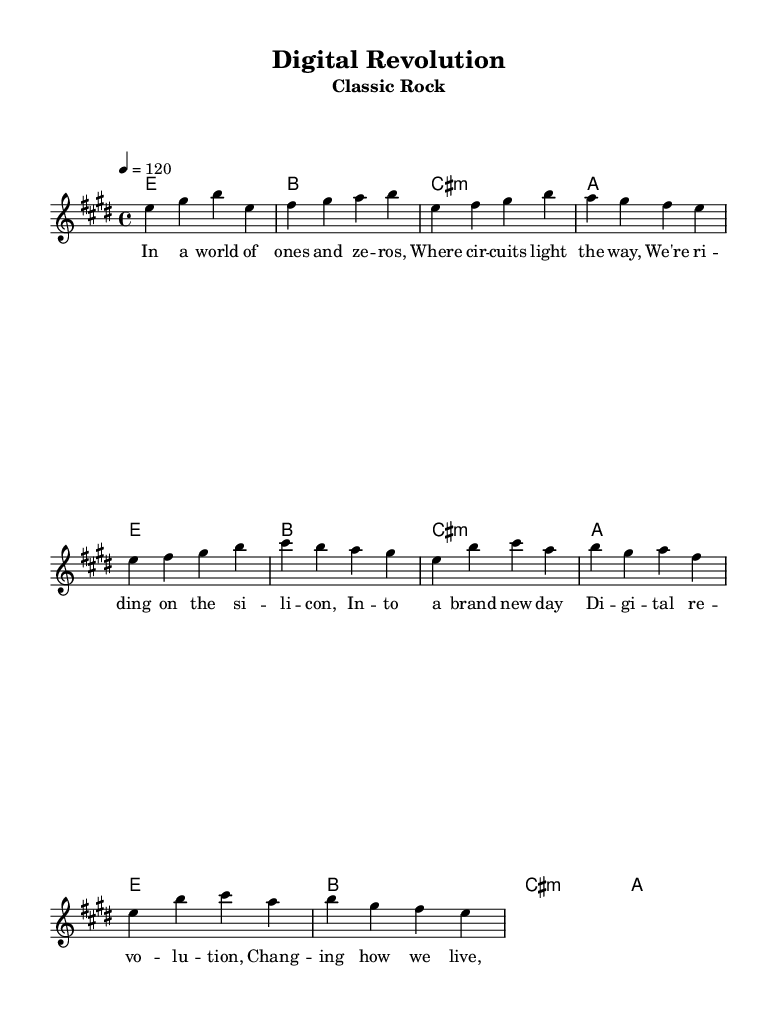What is the key signature of this music? The key signature is indicated in the global section and shows two sharps, which corresponds to E major.
Answer: E major What is the time signature of the piece? The time signature is present in the global section as a fraction, in this case, 4/4, which indicates four beats per measure.
Answer: 4/4 What is the tempo marking for the music? The tempo marking is found in the global section, indicating a tempo of 120 beats per minute in quarter note values.
Answer: 120 How many measures are in the chorus? The chorus is indicated by its lyric mode, counting the measures where the lyrics belong shows it's four measures long.
Answer: 4 What is the first chord in the piece? The first chord is found in the harmonies section under the intro, which indicates an E major chord as the initial harmony.
Answer: E How many verses are included before the chorus? The verses follow a pattern that is distinct from the chorus section, with one verse being present before the first chorus. By counting the lyric lines in the verse section, it's clear there is one verse before the chorus.
Answer: 1 What thematic concept is highlighted in the lyrics? Analyzing the lyrics, the theme revolves around technology and its transformative effects on life, explicitly mentioned in the repeating phrases of "digital revolution."
Answer: Technology 